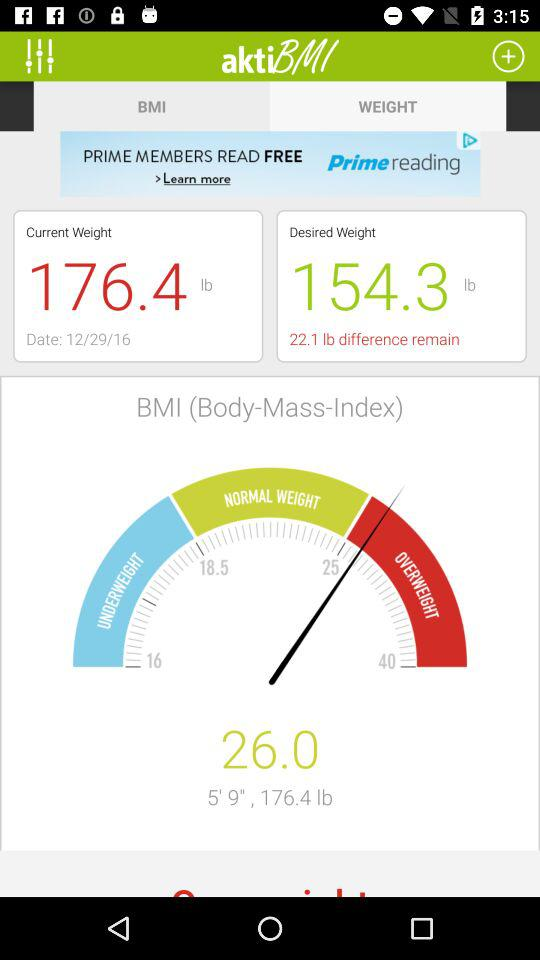What is the current weight? The current weight is 176.4 lbs. 